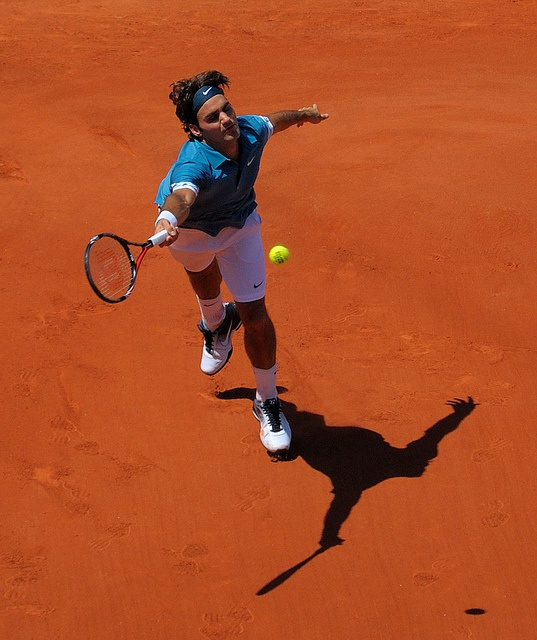Describe the objects in this image and their specific colors. I can see people in red, black, brown, purple, and maroon tones, tennis racket in red, brown, black, and maroon tones, and sports ball in red, olive, and yellow tones in this image. 